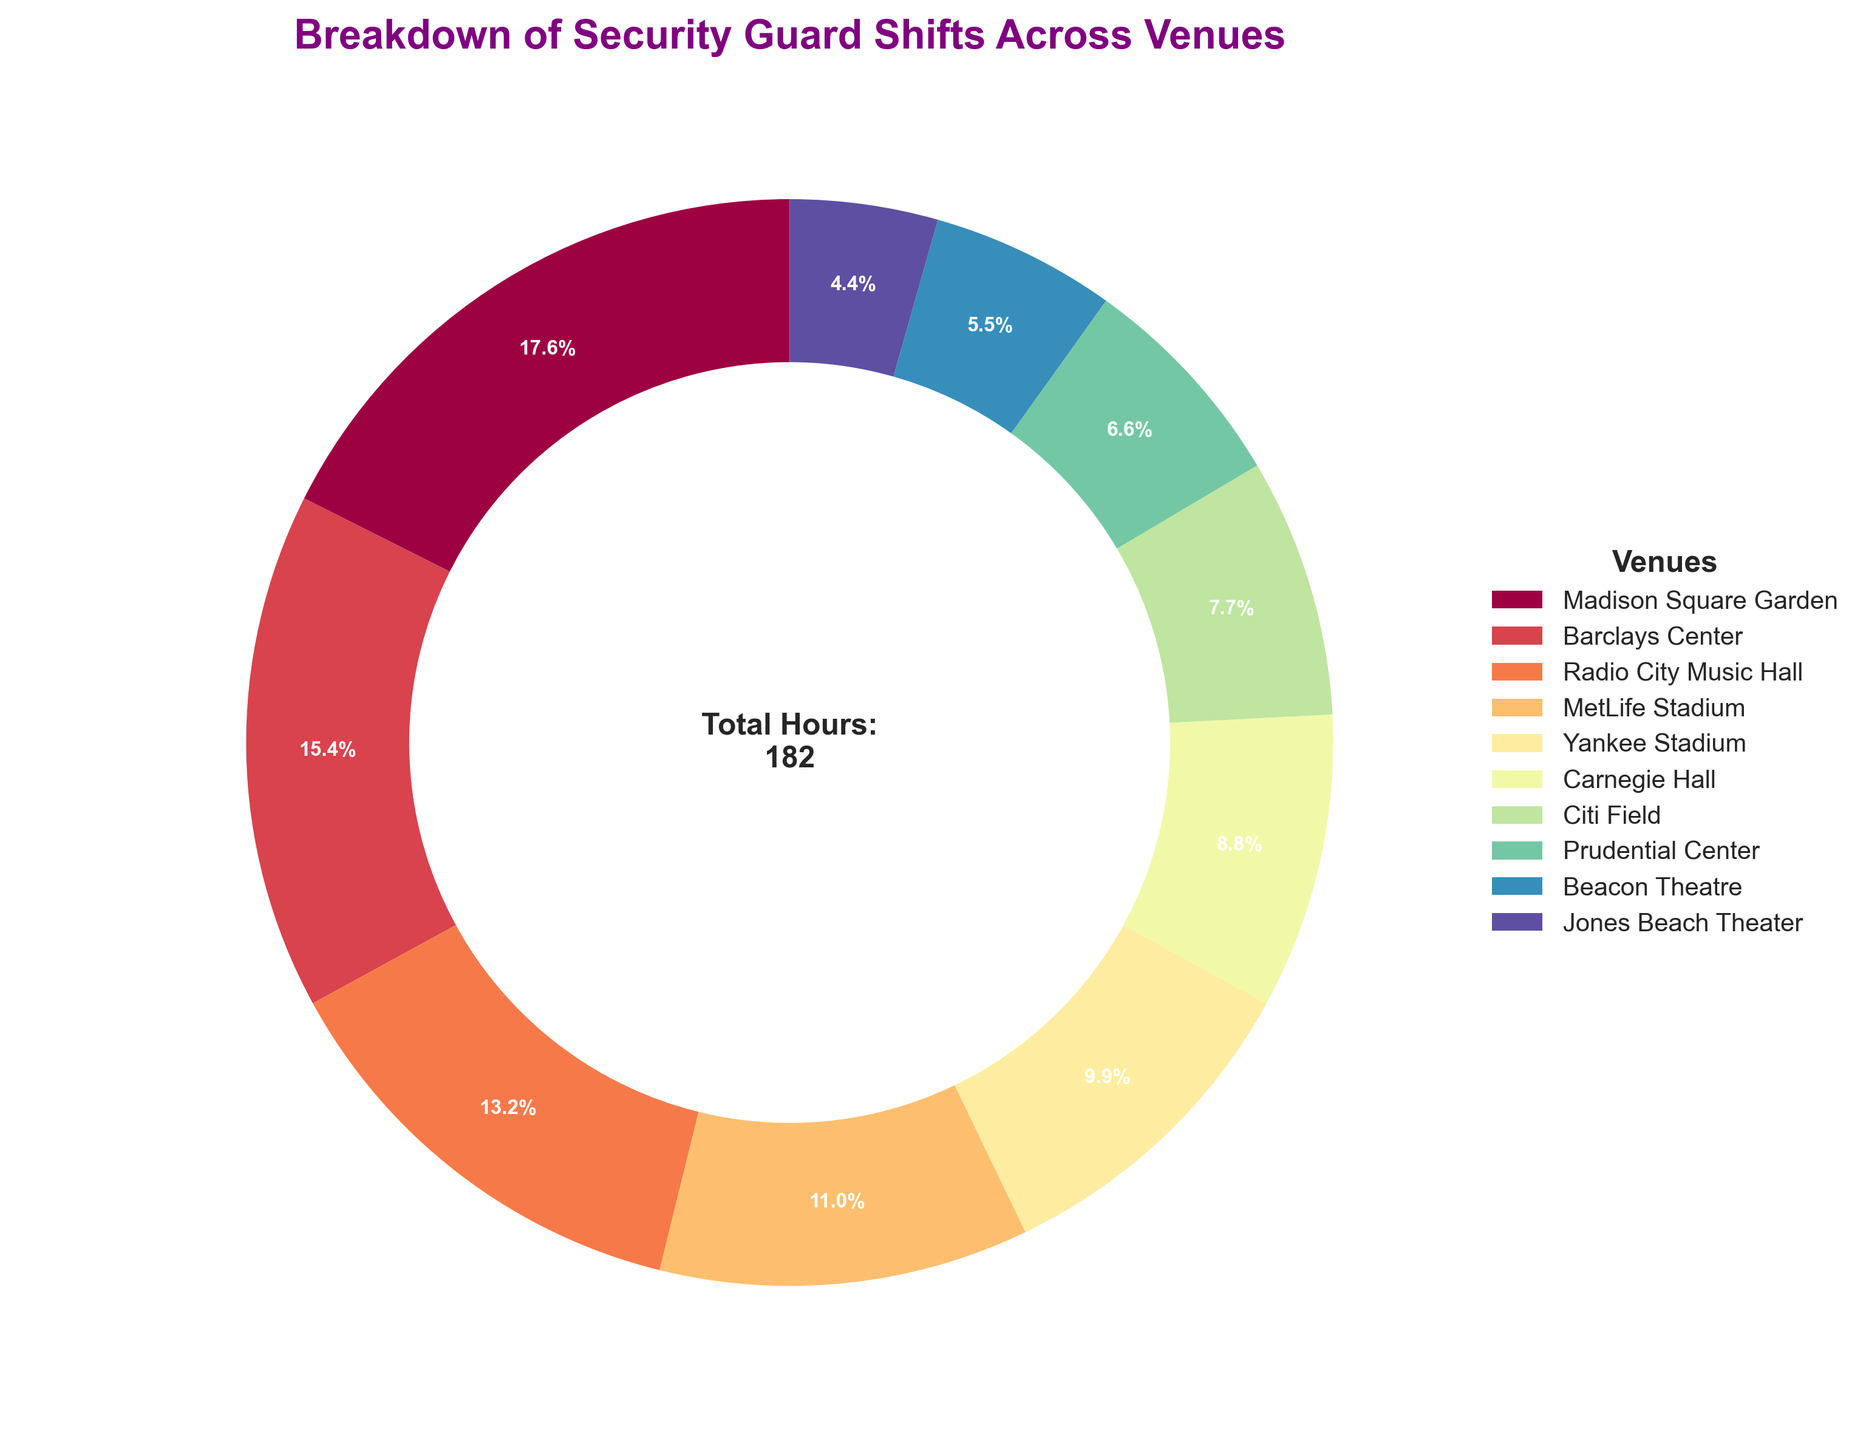What percentage of security guard shifts are at Madison Square Garden? The slice labeled "Madison Square Garden" has an associated percentage.  This percentage represents its proportion of the total hours.
Answer: 19.5% Which venue has the fewest security guard shifts? The venue with the smallest slice represents the fewest total shifts. This is identified as "Jones Beach Theater."
Answer: Jones Beach Theater How many hours are dedicated to shifts at Radio City Music Hall and MetLife Stadium combined? Add the hours dedicated to Radio City Music Hall (24) and MetLife Stadium (20) together to find the combined total.
Answer: 44 Is the total number of hours at Barclays Center greater than the combined hours at Yankee Stadium and Carnegie Hall? Compare the hours at Barclays Center (28) with the combined hours of Yankee Stadium (18) and Carnegie Hall (16), which together total 34. 28 is less than 34.
Answer: No What is the difference in the number of hours between Citi Field and Prudential Center? Subtract the hours of Prudential Center (12) from Citi Field (14) to determine the difference.
Answer: 2 Which venues have more than 20 hours of security guard shifts? The slices representing venues with above 20 hours include Madison Square Garden (32), Barclays Center (28), and Radio City Music Hall (24).
Answer: Madison Square Garden, Barclays Center, Radio City Music Hall How many total hours are represented in the pie chart? The sum of all hours for each venue can be found in the center text displayed within the pie chart.
Answer: 182 Which venue constitutes exactly 10% of security guard shifts? The sections of the pie chart are labeled with percentages. Identifying the slice that represents 10%, labeled "Yankee Stadium," provides the answer.
Answer: Yankee Stadium What is the total percentage of security guard shifts allocated to Beacon Theatre and Prudential Center? Sum the individual percentages for Beacon Theatre (5.5%) and Prudential Center (6.6%).
Answer: 12.1% Are there more hours allocated to Carnegie Hall or Yankee Stadium? Compare the sizes of the slices corresponding to Carnegie Hall and Yankee Stadium, with Carnegie Hall having 16 hours and Yankee Stadium having 18 hours.
Answer: Yankee Stadium 